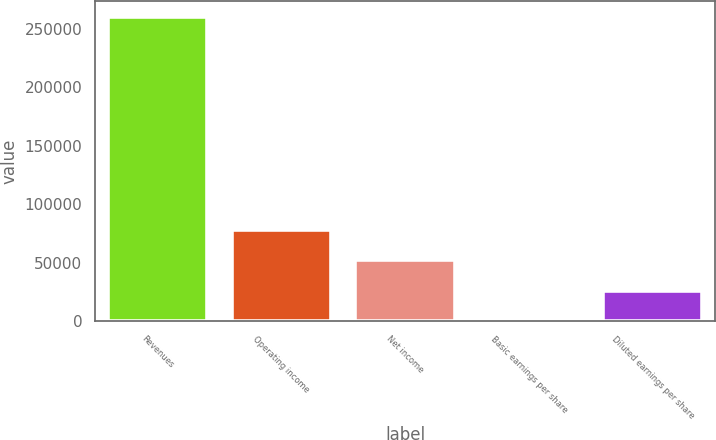<chart> <loc_0><loc_0><loc_500><loc_500><bar_chart><fcel>Revenues<fcel>Operating income<fcel>Net income<fcel>Basic earnings per share<fcel>Diluted earnings per share<nl><fcel>260697<fcel>78209.4<fcel>52139.7<fcel>0.42<fcel>26070.1<nl></chart> 